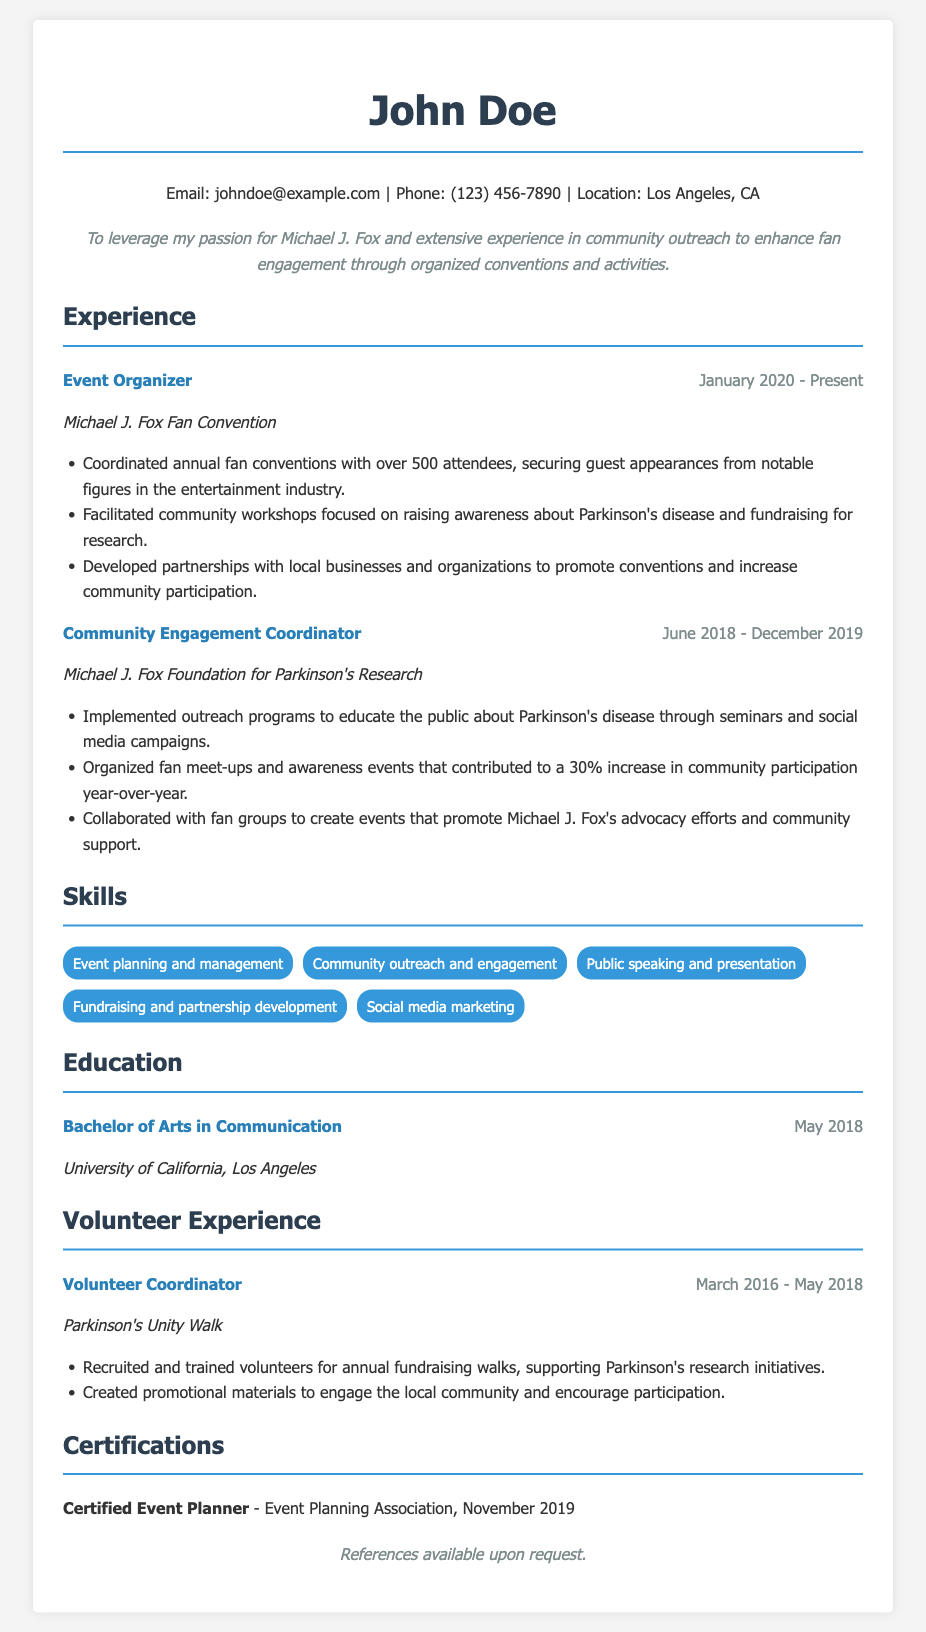what is the name of the individual in the CV? The name of the individual is stated at the top of the document as "John Doe."
Answer: John Doe what is the title of the current position held by John Doe? The title of the current position is listed in the experience section, specifically "Event Organizer."
Answer: Event Organizer when did John Doe start working as an Event Organizer? The start date is mentioned next to the title in the experience section, which is "January 2020."
Answer: January 2020 how many attendees are typically at the annual fan conventions organized by John Doe? The number of attendees is provided in the experience section, noting "over 500 attendees."
Answer: over 500 attendees what was the percentage increase in community participation due to John Doe's events? The percentage increase is detailed in the experience section as "30% increase in community participation."
Answer: 30% who did John Doe work for as a Community Engagement Coordinator? The organization John Doe worked for is indicated in the experience section as "Michael J. Fox Foundation for Parkinson's Research."
Answer: Michael J. Fox Foundation for Parkinson's Research what educational degree does John Doe hold? The educational degree is specified in the education section as "Bachelor of Arts in Communication."
Answer: Bachelor of Arts in Communication what certification does John Doe have? The certification is mentioned in the certifications section as "Certified Event Planner."
Answer: Certified Event Planner which organization did John Doe volunteer for as a Volunteer Coordinator? The organization for which John Doe volunteered is listed in the volunteer experience section as "Parkinson's Unity Walk."
Answer: Parkinson's Unity Walk 